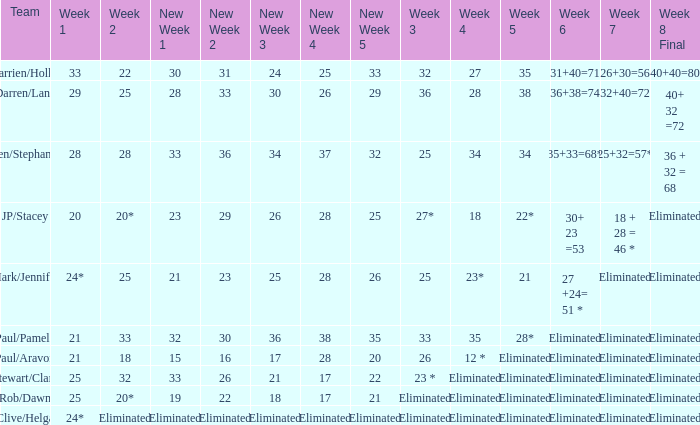Name the team for week 1 of 33 Darrien/Hollie. 